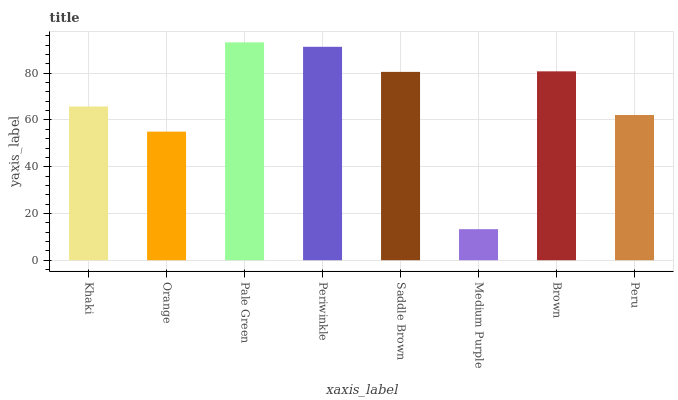Is Medium Purple the minimum?
Answer yes or no. Yes. Is Pale Green the maximum?
Answer yes or no. Yes. Is Orange the minimum?
Answer yes or no. No. Is Orange the maximum?
Answer yes or no. No. Is Khaki greater than Orange?
Answer yes or no. Yes. Is Orange less than Khaki?
Answer yes or no. Yes. Is Orange greater than Khaki?
Answer yes or no. No. Is Khaki less than Orange?
Answer yes or no. No. Is Saddle Brown the high median?
Answer yes or no. Yes. Is Khaki the low median?
Answer yes or no. Yes. Is Orange the high median?
Answer yes or no. No. Is Pale Green the low median?
Answer yes or no. No. 